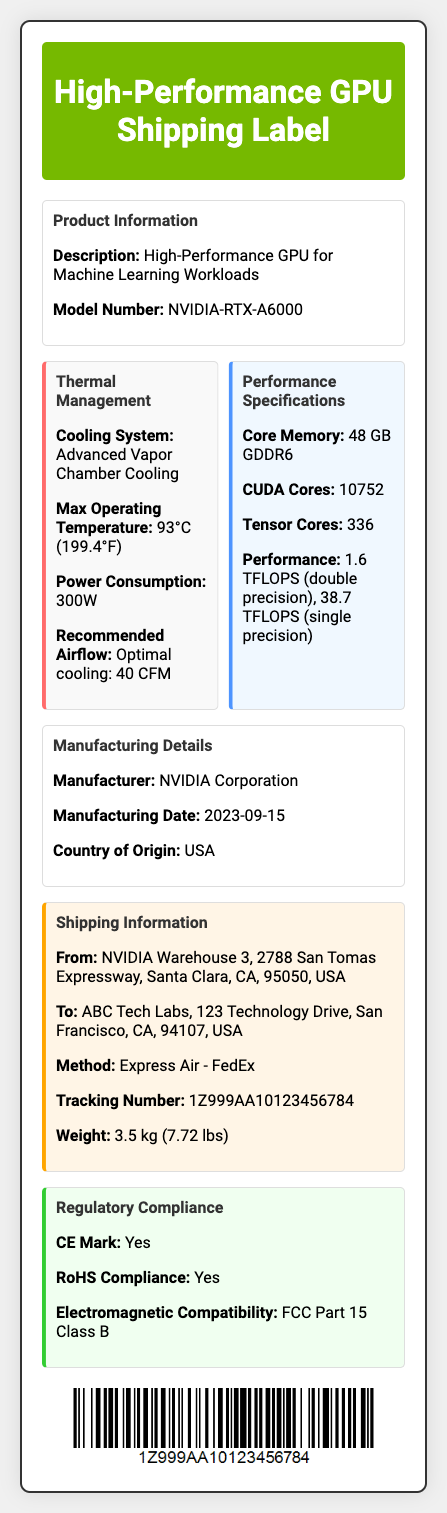What is the model number? The model number is specified in the Product Information section of the document.
Answer: NVIDIA-RTX-A6000 What is the maximum operating temperature? The maximum operating temperature is mentioned in the Thermal Management section.
Answer: 93°C (199.4°F) How much power does the GPU consume? The power consumption is detailed in the Thermal Management section of the shipping label.
Answer: 300W What is the weight of the package? The weight is listed in the Shipping Information section of the document.
Answer: 3.5 kg (7.72 lbs) Where is the manufacturer located? The location of the manufacturer is indicated in the Manufacturing Details section.
Answer: USA How many CUDA cores does the GPU have? The number of CUDA cores is provided in the Performance Specifications section.
Answer: 10752 What is the shipping method used? The shipping method is specified in the Shipping Information section.
Answer: Express Air - FedEx What is the tracking number? The tracking number is found in the Shipping Information section of the document.
Answer: 1Z999AA10123456784 Is the GPU CE marked? The CE Mark status is reported under the Regulatory Compliance section.
Answer: Yes 